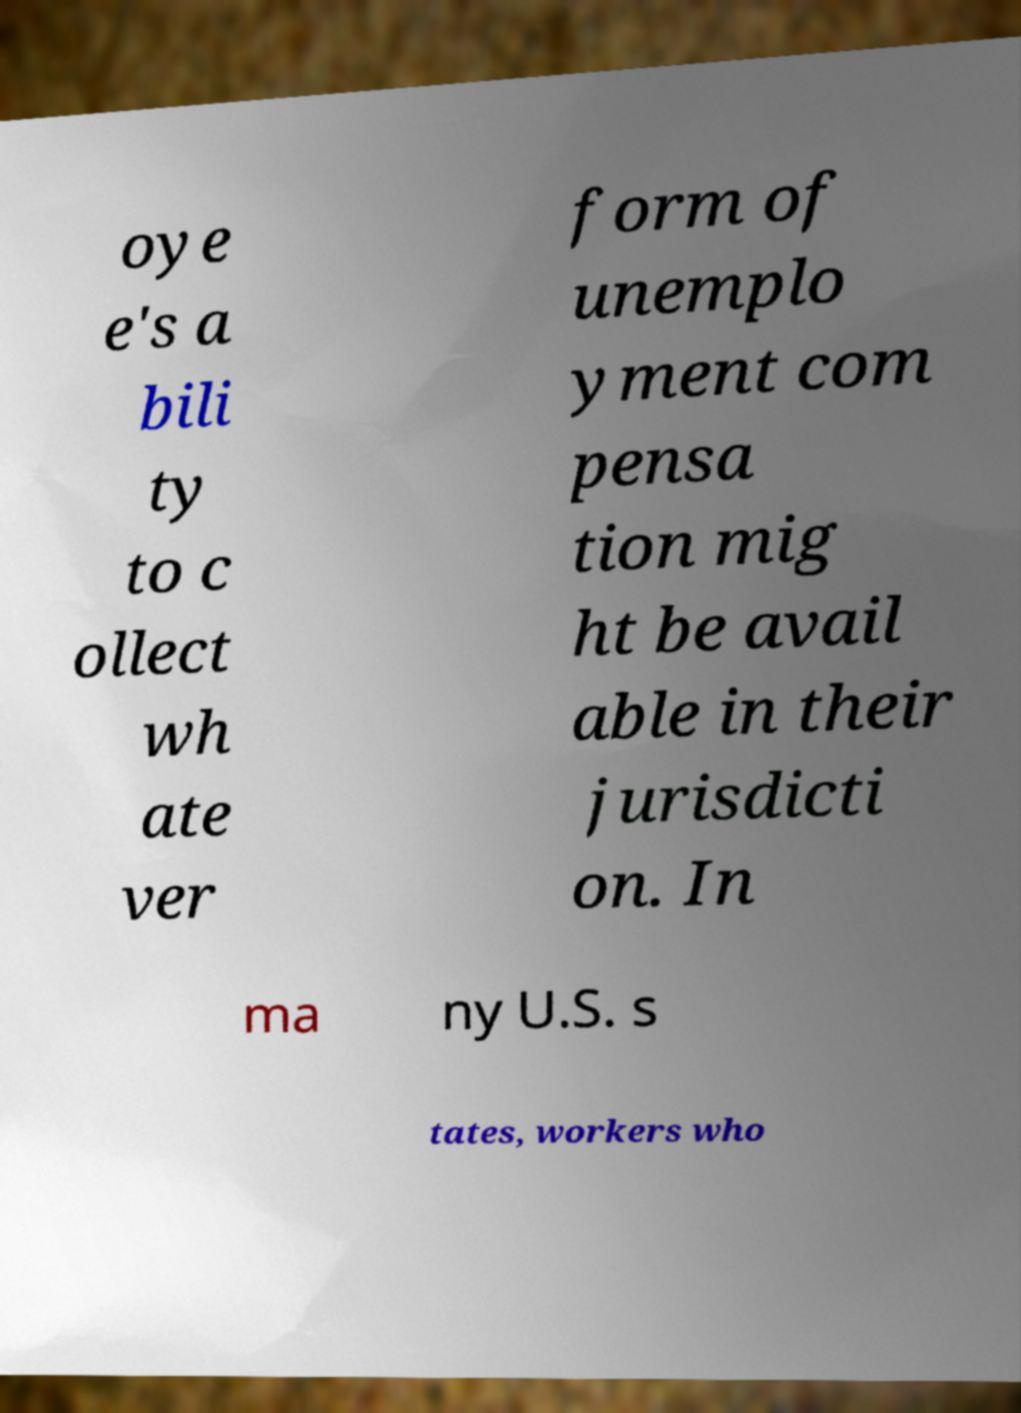Could you assist in decoding the text presented in this image and type it out clearly? oye e's a bili ty to c ollect wh ate ver form of unemplo yment com pensa tion mig ht be avail able in their jurisdicti on. In ma ny U.S. s tates, workers who 